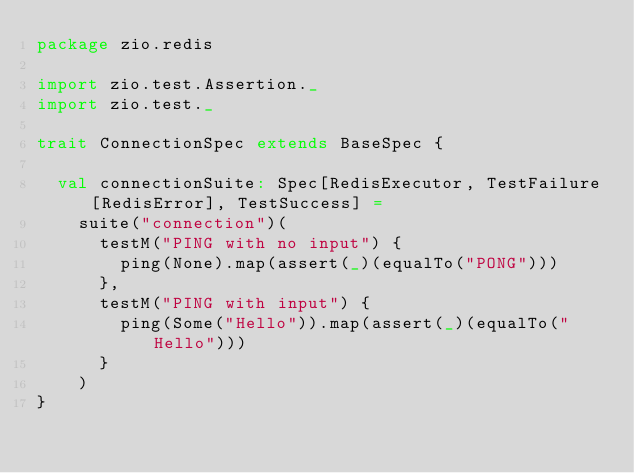Convert code to text. <code><loc_0><loc_0><loc_500><loc_500><_Scala_>package zio.redis

import zio.test.Assertion._
import zio.test._

trait ConnectionSpec extends BaseSpec {

  val connectionSuite: Spec[RedisExecutor, TestFailure[RedisError], TestSuccess] =
    suite("connection")(
      testM("PING with no input") {
        ping(None).map(assert(_)(equalTo("PONG")))
      },
      testM("PING with input") {
        ping(Some("Hello")).map(assert(_)(equalTo("Hello")))
      }
    )
}
</code> 